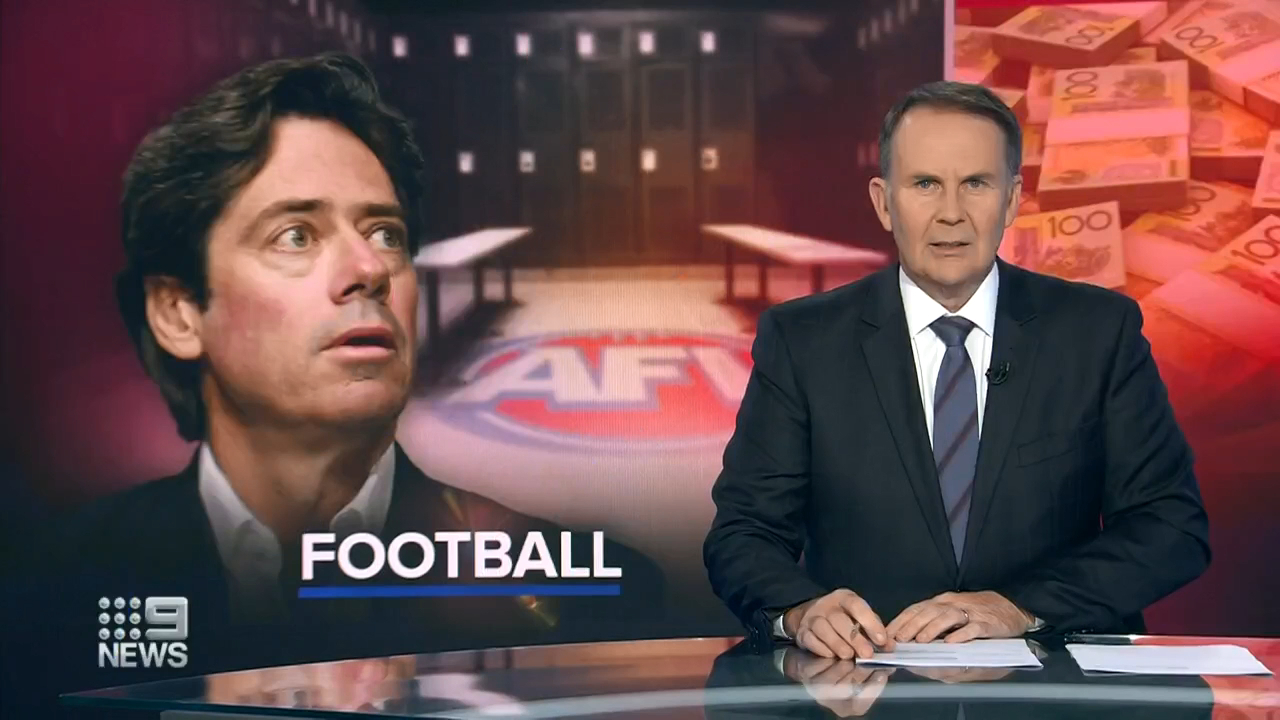Considering the expression on the news anchor's face and the background graphic, what could be the tone or mood of the news segment? The tone or mood of the news segment seems to be serious and potentially concerning. Observing the news anchor's serious expression and intense gaze, along with the background graphics, reveals a deeper context. The presence of a man looking tense, coupled with the blurred image of currency notes, indicates that the segment is likely addressing a significant issue within the realm of Australian Football. Topics such as financial mismanagement, controversies, or other impactful events could be the focus, requiring a solemn and careful presentation by the news anchor. 